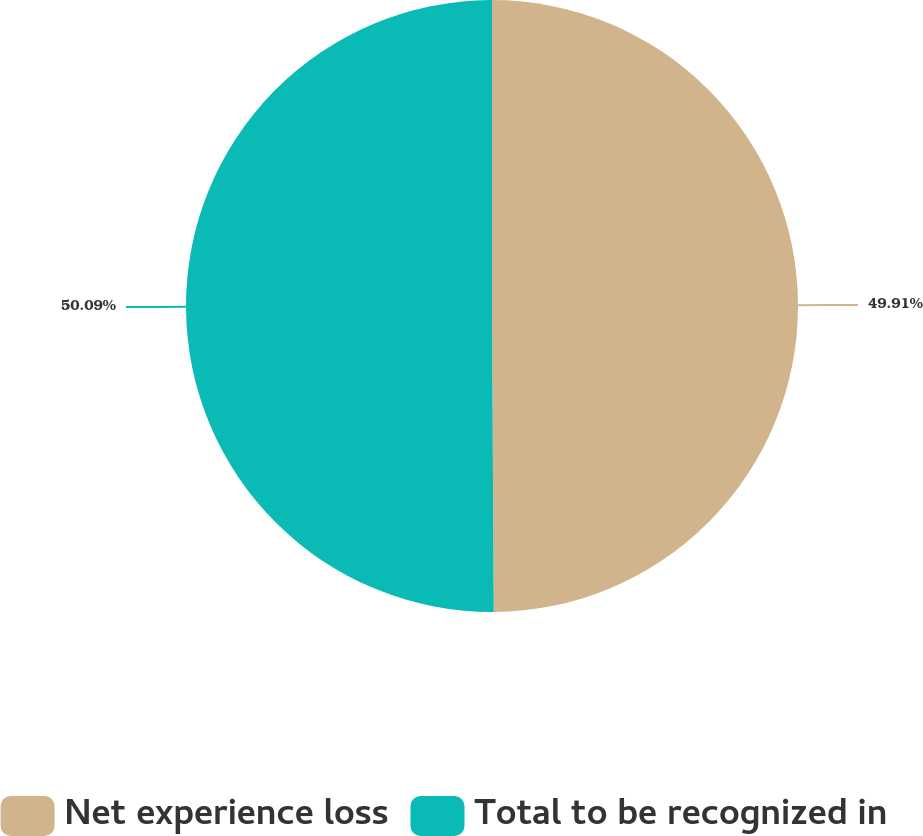Convert chart to OTSL. <chart><loc_0><loc_0><loc_500><loc_500><pie_chart><fcel>Net experience loss<fcel>Total to be recognized in<nl><fcel>49.91%<fcel>50.09%<nl></chart> 